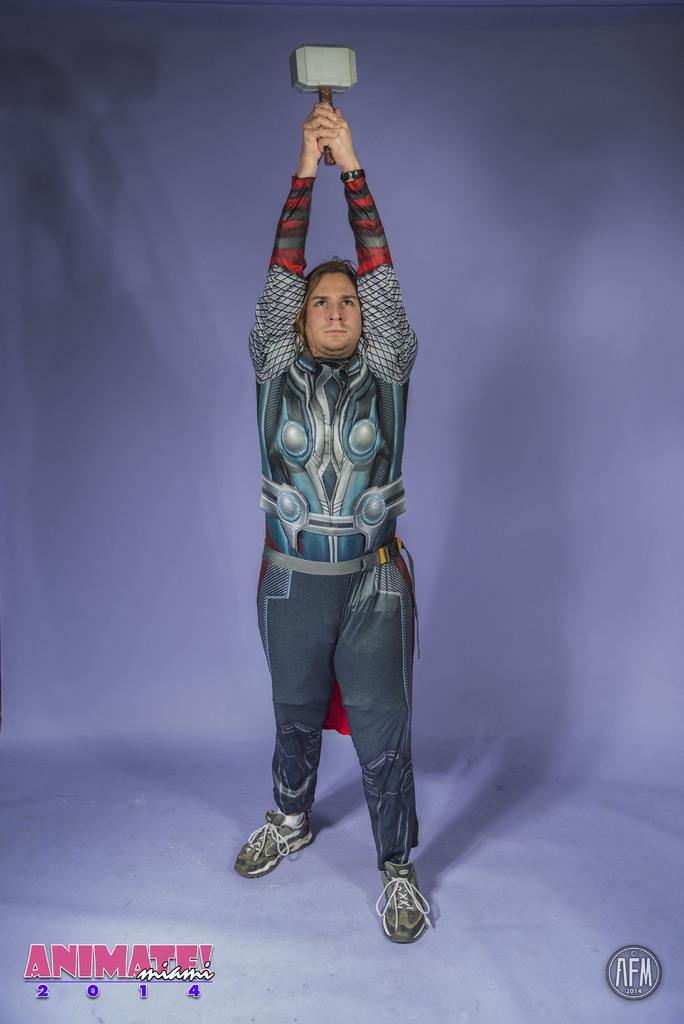What is the main subject of the image? There is a person standing in the image. What is the person wearing in the image? The person is wearing a costume. What object is the person holding in their hand? The person is holding Thor's hammer in their hand. How many horses are visible in the image? There are no horses present in the image. What is the size of the map being held by the person in the image? There is no map present in the image; the person is holding Thor's hammer. 